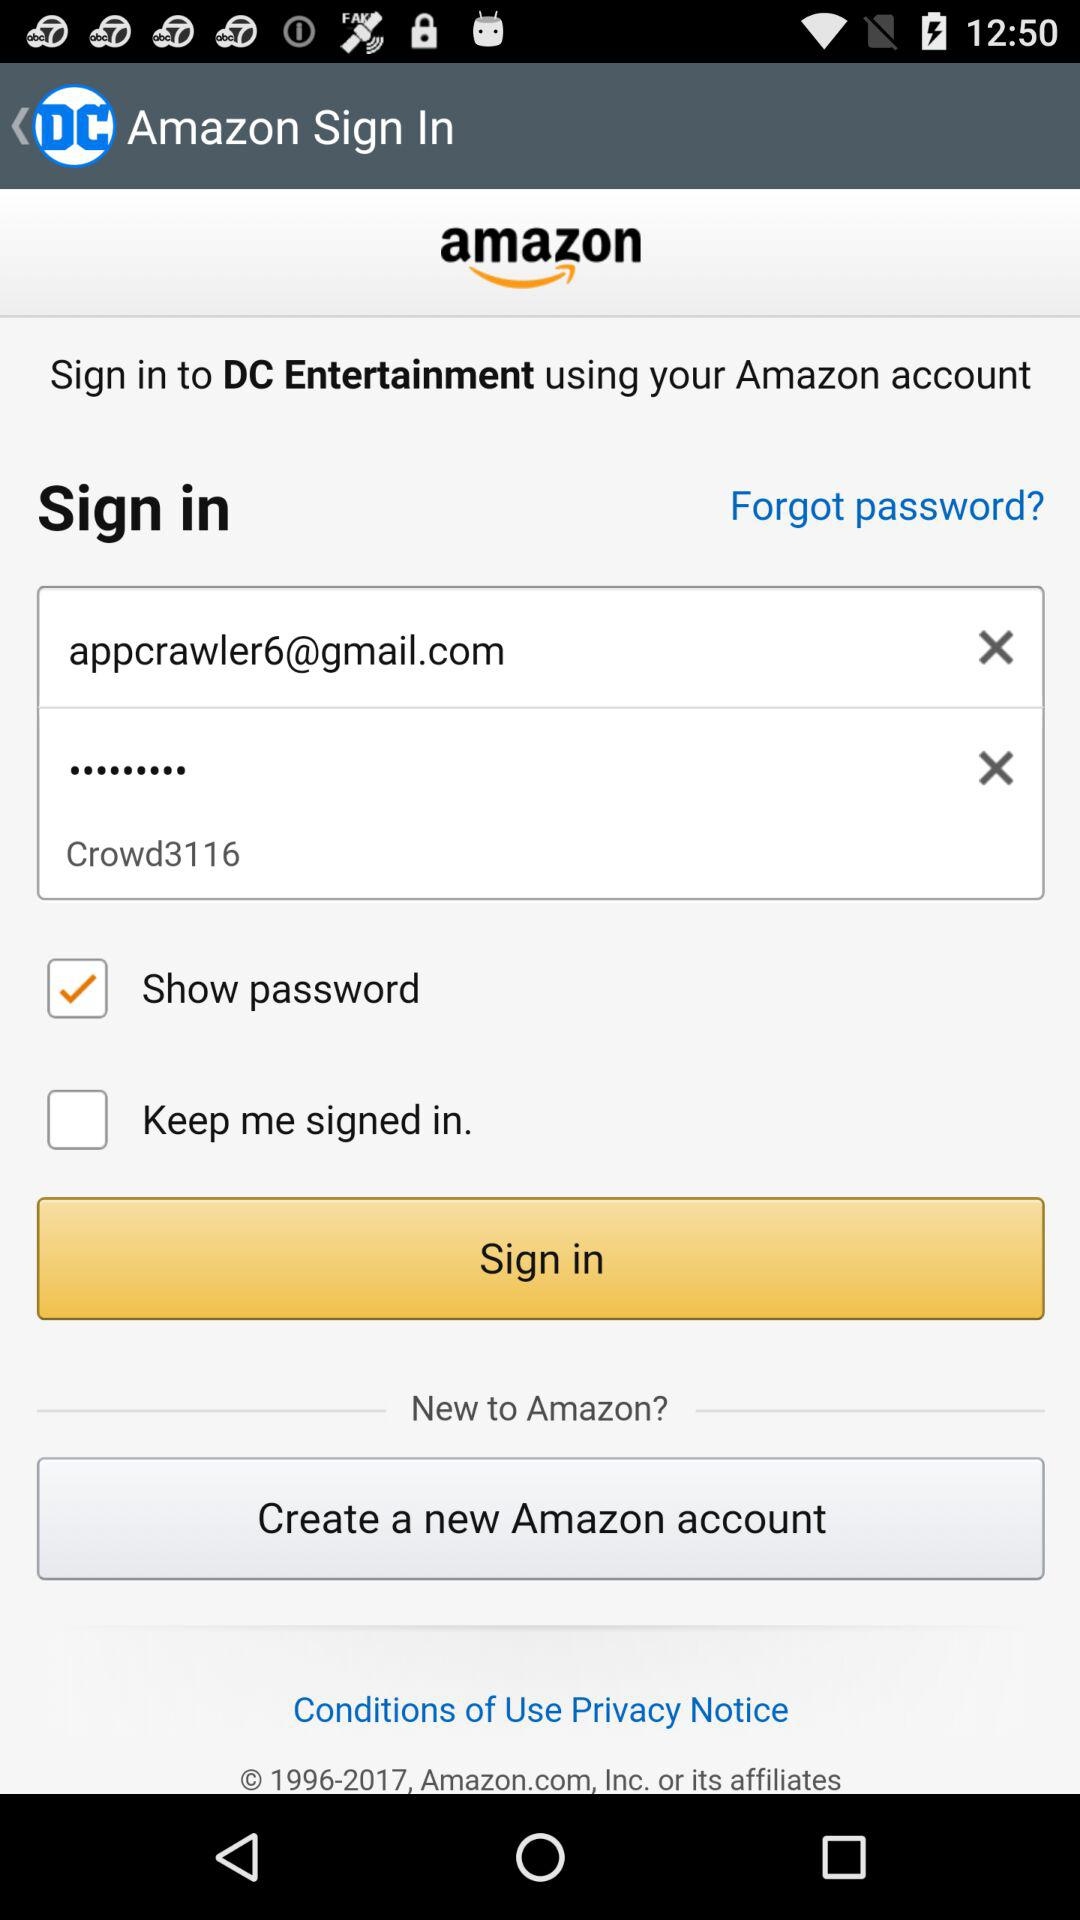What is the email address? The email address is appcrawler6@gmail.com. 